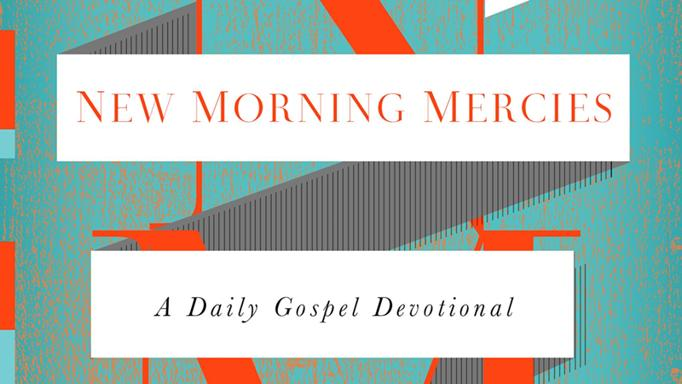What mood does the design of this devotional evoke, and how might it affect a reader's engagement? The design of the devotional evokes a mood of optimism and vibrancy, reflected through the use of bright orange which typically symbolizes enthusiasm and energy. This might affect a reader's engagement positively by forging an uplifting and energizing reading experience, which could help in daily spiritual renewals and reflections. 